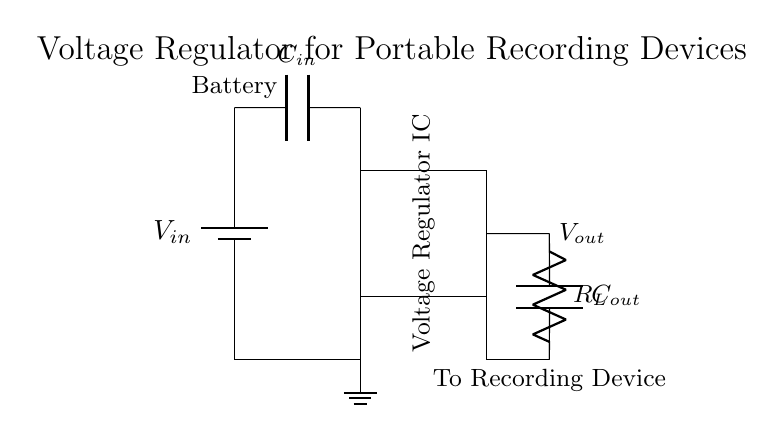What is the input voltage symbol shown in the circuit? The input voltage is represented by the symbol V in the battery icon.
Answer: Vin What component is used to stabilize the output voltage? The component that stabilizes the output voltage is shown as a rectangular block labeled "Voltage Regulator IC".
Answer: Voltage Regulator IC How many capacitors are present in the circuit? The circuit has two capacitors, one labeled C_in and the other C_out.
Answer: Two What is the output load of the circuit? The output load is represented as R_L, which stands for the output resistor connected to the voltage regulator.
Answer: R_L What is the purpose of capacitor C_out in this circuit? Capacitor C_out is used to filter and stabilize the output voltage, ensuring smooth current delivery to the recording device.
Answer: Stablization and filtering What is the ground connection used for in the circuit? The ground connection provides a reference point for the voltage levels in the circuit, completing the circuit by allowing current to return.
Answer: Reference point 